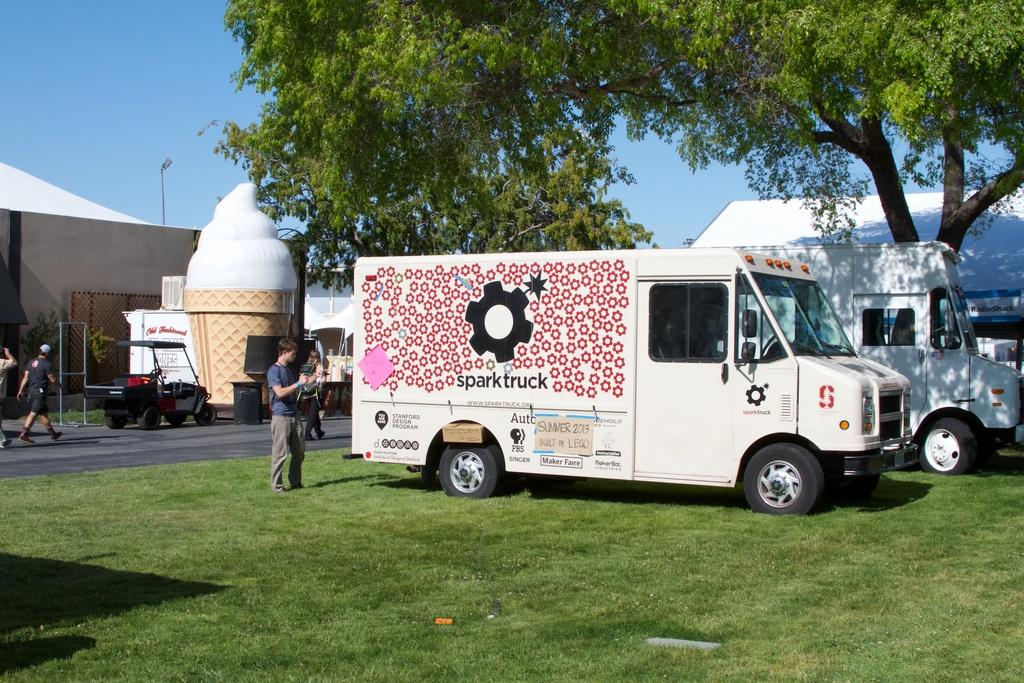What can be seen on the ground in the image? There are several vehicles parked on the ground, and a group of persons is standing on the ground. What is visible in the background of the image? There are buildings, a group of trees, and the sky visible in the background of the image. Can you tell me how many fans are visible in the image? There are no fans present in the image. Is there a crook standing among the group of persons in the image? There is no mention of a crook or any specific individuals in the image, only a group of persons. What type of scissors can be seen cutting the trees in the background? There are no scissors or any cutting activity involving trees in the image. 